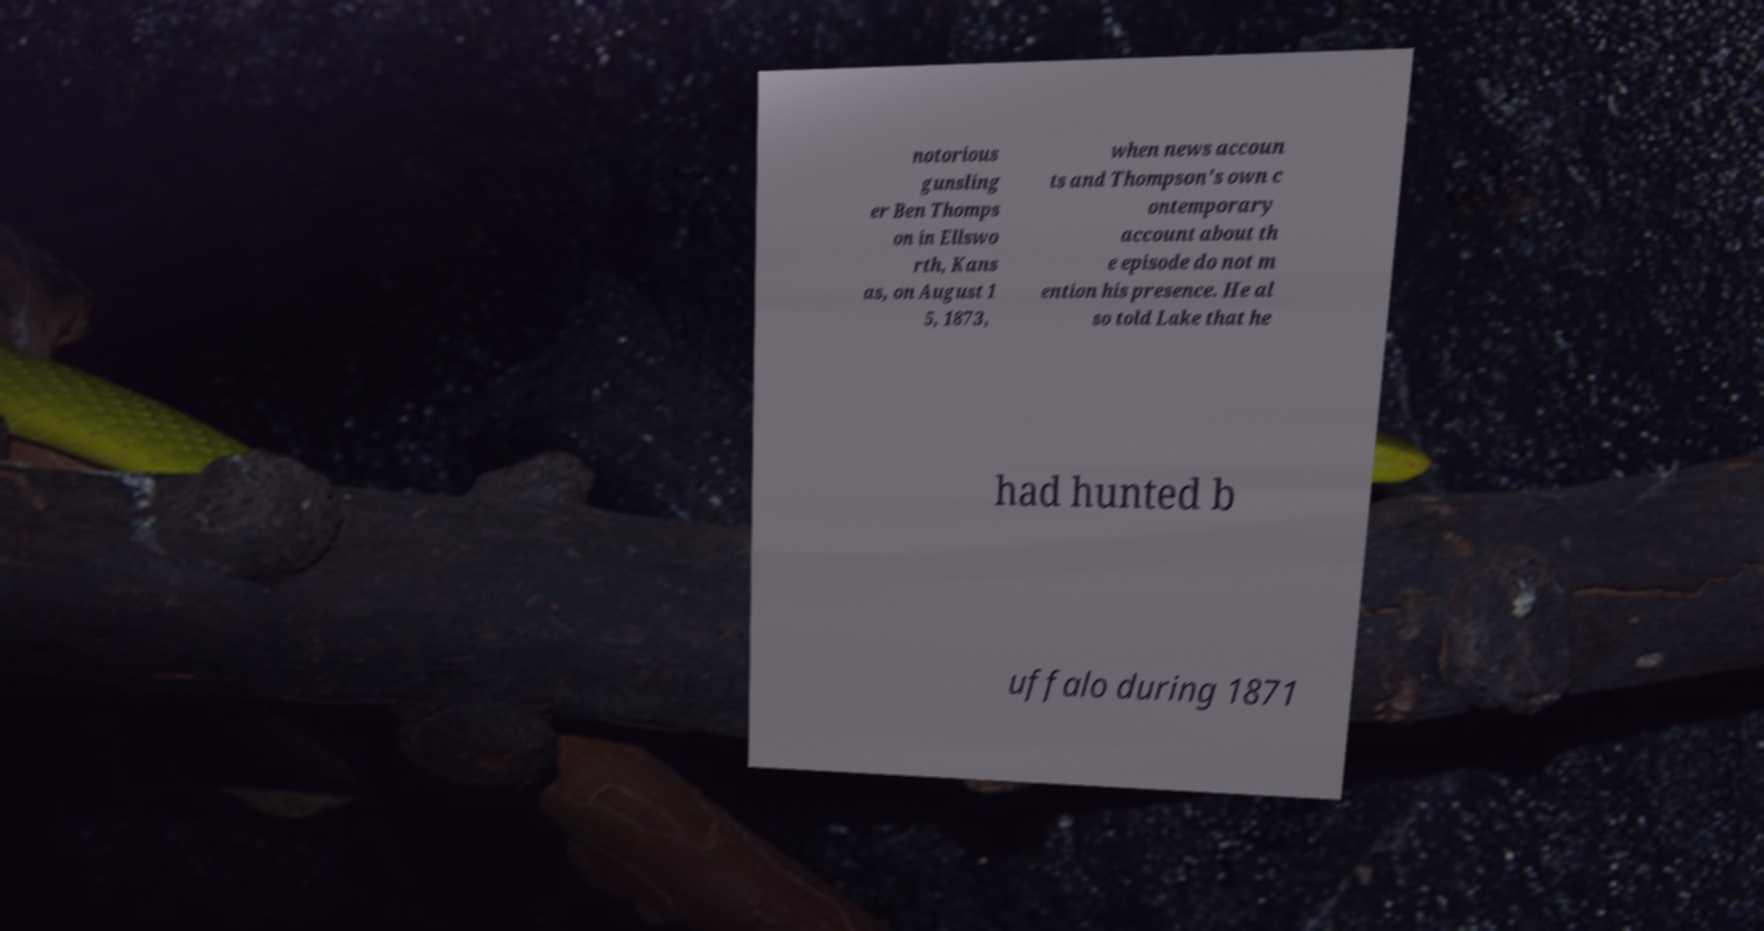Could you extract and type out the text from this image? notorious gunsling er Ben Thomps on in Ellswo rth, Kans as, on August 1 5, 1873, when news accoun ts and Thompson's own c ontemporary account about th e episode do not m ention his presence. He al so told Lake that he had hunted b uffalo during 1871 